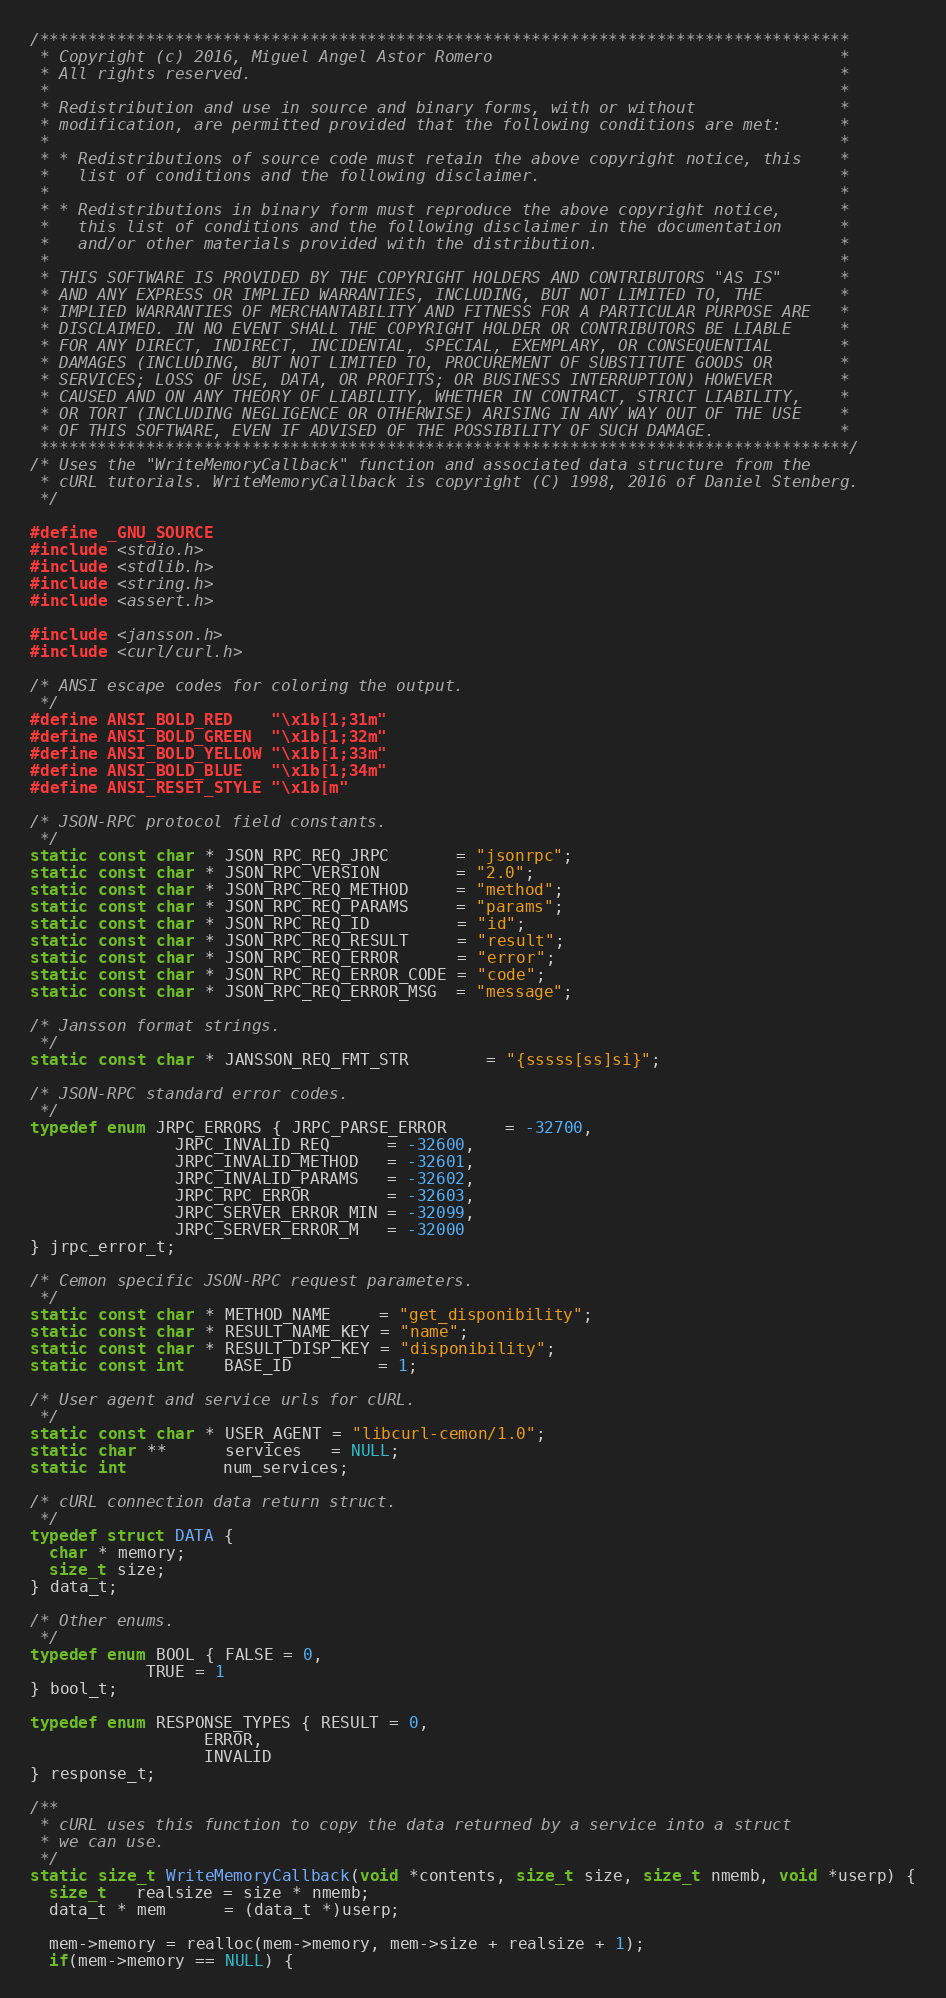Convert code to text. <code><loc_0><loc_0><loc_500><loc_500><_C_>/************************************************************************************
 * Copyright (c) 2016, Miguel Angel Astor Romero                                    *
 * All rights reserved.                                                             *
 *                                                                                  *
 * Redistribution and use in source and binary forms, with or without               *
 * modification, are permitted provided that the following conditions are met:      *
 *                                                                                  *
 * * Redistributions of source code must retain the above copyright notice, this    *
 *   list of conditions and the following disclaimer.                               *
 *                                                                                  * 
 * * Redistributions in binary form must reproduce the above copyright notice,      *
 *   this list of conditions and the following disclaimer in the documentation      *
 *   and/or other materials provided with the distribution.                         *
 *                                                                                  *
 * THIS SOFTWARE IS PROVIDED BY THE COPYRIGHT HOLDERS AND CONTRIBUTORS "AS IS"      *
 * AND ANY EXPRESS OR IMPLIED WARRANTIES, INCLUDING, BUT NOT LIMITED TO, THE        *
 * IMPLIED WARRANTIES OF MERCHANTABILITY AND FITNESS FOR A PARTICULAR PURPOSE ARE   *
 * DISCLAIMED. IN NO EVENT SHALL THE COPYRIGHT HOLDER OR CONTRIBUTORS BE LIABLE     *
 * FOR ANY DIRECT, INDIRECT, INCIDENTAL, SPECIAL, EXEMPLARY, OR CONSEQUENTIAL       *
 * DAMAGES (INCLUDING, BUT NOT LIMITED TO, PROCUREMENT OF SUBSTITUTE GOODS OR       *
 * SERVICES; LOSS OF USE, DATA, OR PROFITS; OR BUSINESS INTERRUPTION) HOWEVER       *
 * CAUSED AND ON ANY THEORY OF LIABILITY, WHETHER IN CONTRACT, STRICT LIABILITY,    *
 * OR TORT (INCLUDING NEGLIGENCE OR OTHERWISE) ARISING IN ANY WAY OUT OF THE USE    *
 * OF THIS SOFTWARE, EVEN IF ADVISED OF THE POSSIBILITY OF SUCH DAMAGE.             *
 ************************************************************************************/
/* Uses the "WriteMemoryCallback" function and associated data structure from the
 * cURL tutorials. WriteMemoryCallback is copyright (C) 1998, 2016 of Daniel Stenberg.
 */

#define _GNU_SOURCE
#include <stdio.h>
#include <stdlib.h>
#include <string.h>
#include <assert.h>

#include <jansson.h>
#include <curl/curl.h>

/* ANSI escape codes for coloring the output.
 */
#define ANSI_BOLD_RED    "\x1b[1;31m"
#define ANSI_BOLD_GREEN  "\x1b[1;32m"
#define ANSI_BOLD_YELLOW "\x1b[1;33m"
#define ANSI_BOLD_BLUE   "\x1b[1;34m"
#define ANSI_RESET_STYLE "\x1b[m"

/* JSON-RPC protocol field constants.
 */
static const char * JSON_RPC_REQ_JRPC       = "jsonrpc";
static const char * JSON_RPC_VERSION        = "2.0";
static const char * JSON_RPC_REQ_METHOD     = "method";
static const char * JSON_RPC_REQ_PARAMS     = "params";
static const char * JSON_RPC_REQ_ID         = "id";
static const char * JSON_RPC_REQ_RESULT     = "result";
static const char * JSON_RPC_REQ_ERROR      = "error";
static const char * JSON_RPC_REQ_ERROR_CODE = "code";
static const char * JSON_RPC_REQ_ERROR_MSG  = "message";

/* Jansson format strings.
 */
static const char * JANSSON_REQ_FMT_STR        = "{sssss[ss]si}";

/* JSON-RPC standard error codes.
 */
typedef enum JRPC_ERRORS { JRPC_PARSE_ERROR      = -32700,
			   JRPC_INVALID_REQ      = -32600,
			   JRPC_INVALID_METHOD   = -32601,
			   JRPC_INVALID_PARAMS   = -32602,
			   JRPC_RPC_ERROR        = -32603,
			   JRPC_SERVER_ERROR_MIN = -32099,
			   JRPC_SERVER_ERROR_M   = -32000
} jrpc_error_t;

/* Cemon specific JSON-RPC request parameters.
 */
static const char * METHOD_NAME     = "get_disponibility";
static const char * RESULT_NAME_KEY = "name";
static const char * RESULT_DISP_KEY = "disponibility";
static const int    BASE_ID         = 1;

/* User agent and service urls for cURL.
 */
static const char * USER_AGENT = "libcurl-cemon/1.0";
static char **      services   = NULL;
static int          num_services;

/* cURL connection data return struct.
 */
typedef struct DATA {
  char * memory;
  size_t size;
} data_t;

/* Other enums.
 */
typedef enum BOOL { FALSE = 0,
		    TRUE = 1
} bool_t;

typedef enum RESPONSE_TYPES { RESULT = 0,
			      ERROR,
			      INVALID
} response_t;

/**
 * cURL uses this function to copy the data returned by a service into a struct
 * we can use.
 */
static size_t WriteMemoryCallback(void *contents, size_t size, size_t nmemb, void *userp) {
  size_t   realsize = size * nmemb;
  data_t * mem      = (data_t *)userp;
 
  mem->memory = realloc(mem->memory, mem->size + realsize + 1);
  if(mem->memory == NULL) {</code> 